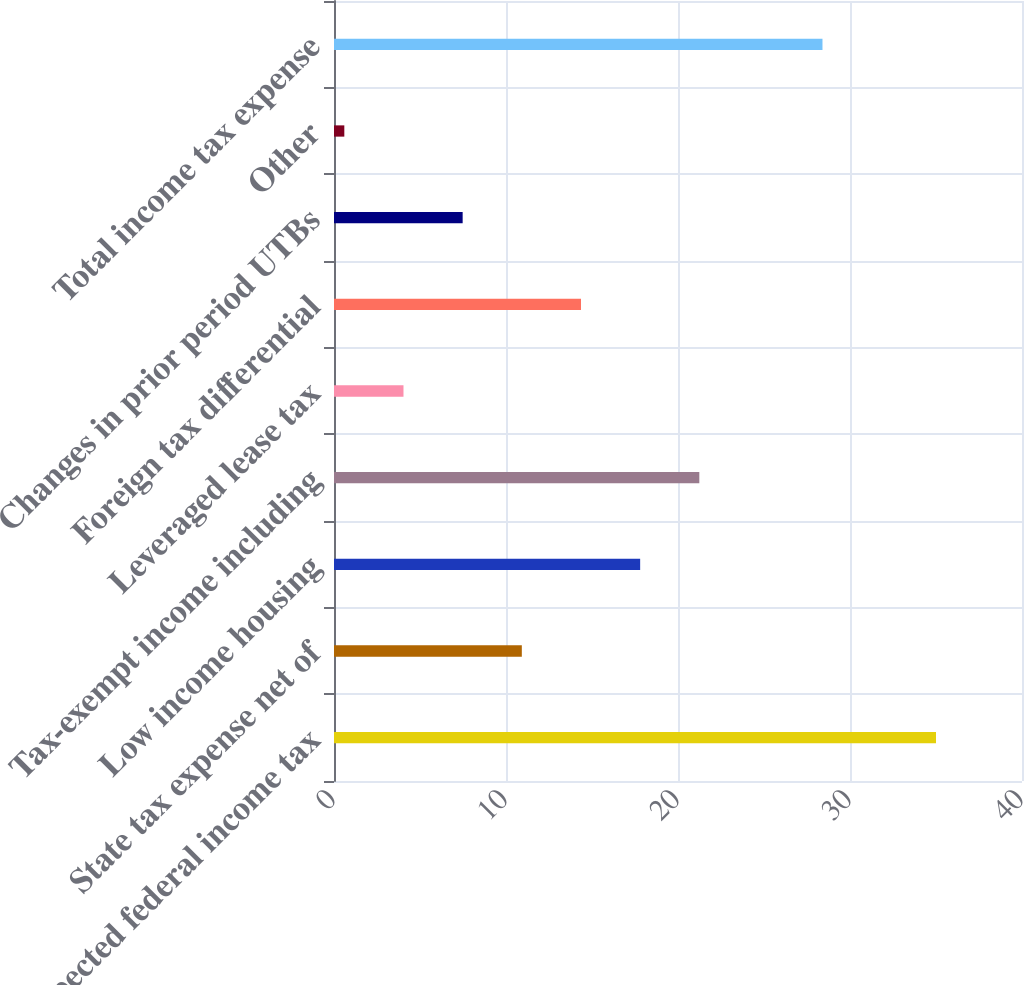Convert chart to OTSL. <chart><loc_0><loc_0><loc_500><loc_500><bar_chart><fcel>Expected federal income tax<fcel>State tax expense net of<fcel>Low income housing<fcel>Tax-exempt income including<fcel>Leveraged lease tax<fcel>Foreign tax differential<fcel>Changes in prior period UTBs<fcel>Other<fcel>Total income tax expense<nl><fcel>35<fcel>10.92<fcel>17.8<fcel>21.24<fcel>4.04<fcel>14.36<fcel>7.48<fcel>0.6<fcel>28.4<nl></chart> 